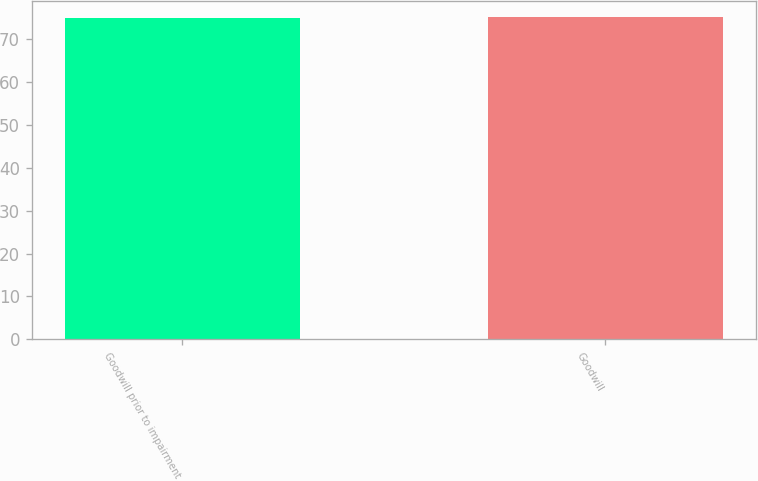Convert chart to OTSL. <chart><loc_0><loc_0><loc_500><loc_500><bar_chart><fcel>Goodwill prior to impairment<fcel>Goodwill<nl><fcel>75.1<fcel>75.2<nl></chart> 